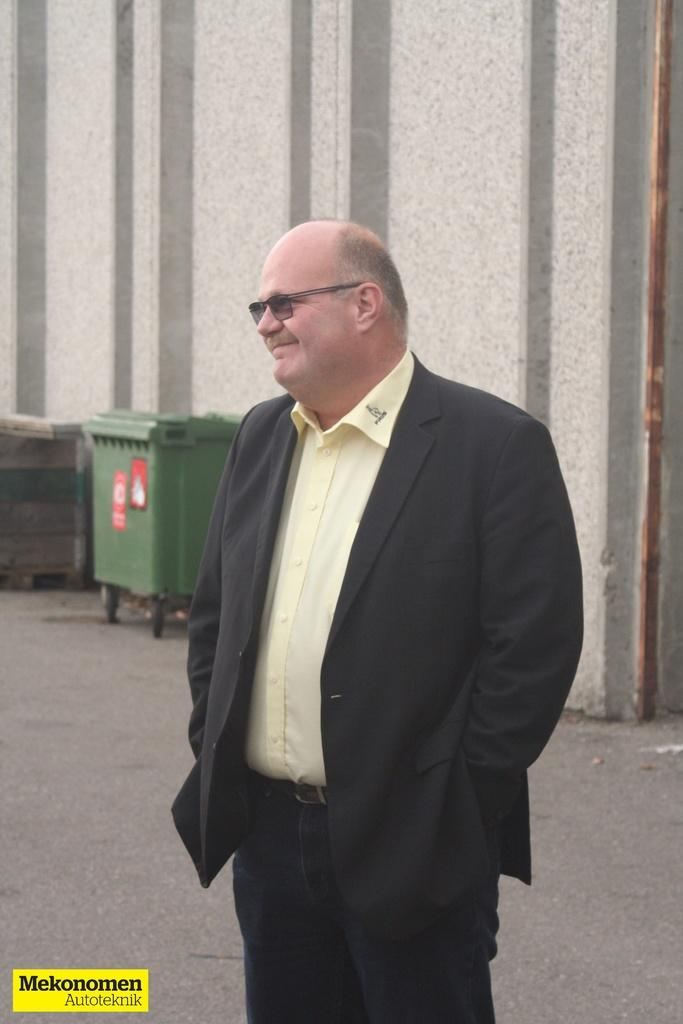Who is the main subject in the image? There is a person in the center of the image. What is the person wearing? The person is wearing a coat and glasses. What can be seen in the background of the image? There are bins and a wall in the background of the image. Is there any text present in the image? Yes, there is some text at the bottom of the image. What type of pin is the person holding in the image? There is no pin present in the image. Can you tell me how many sisters the person in the image has? There is no information about the person's sisters in the image. 